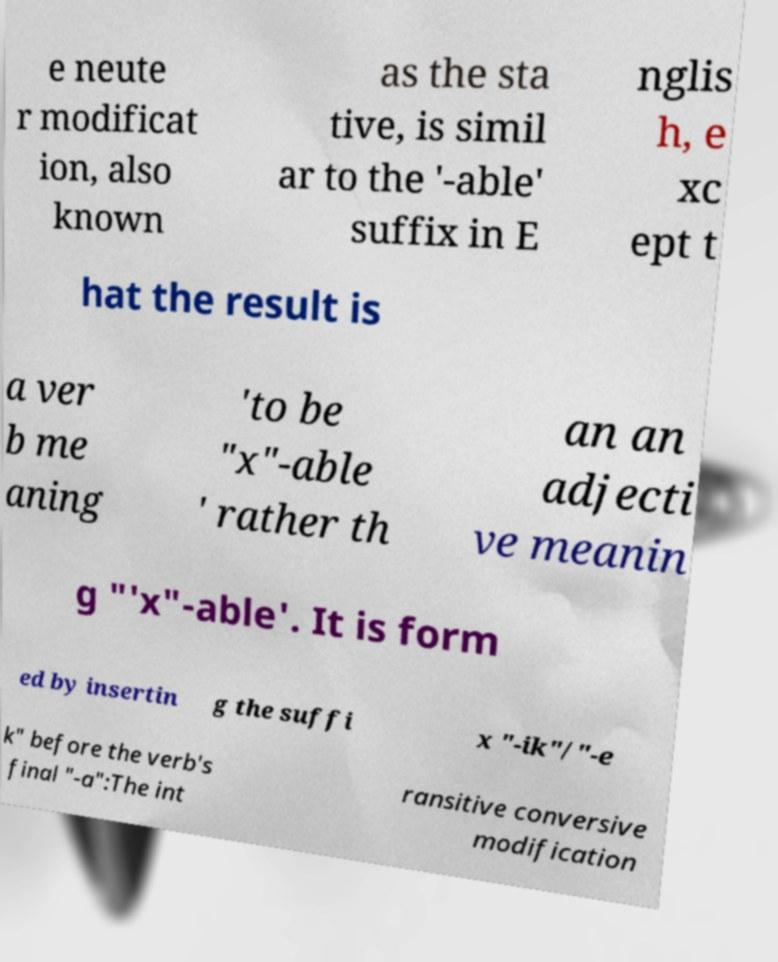Can you accurately transcribe the text from the provided image for me? e neute r modificat ion, also known as the sta tive, is simil ar to the '-able' suffix in E nglis h, e xc ept t hat the result is a ver b me aning 'to be "x"-able ' rather th an an adjecti ve meanin g "'x"-able'. It is form ed by insertin g the suffi x "-ik"/"-e k" before the verb's final "-a":The int ransitive conversive modification 